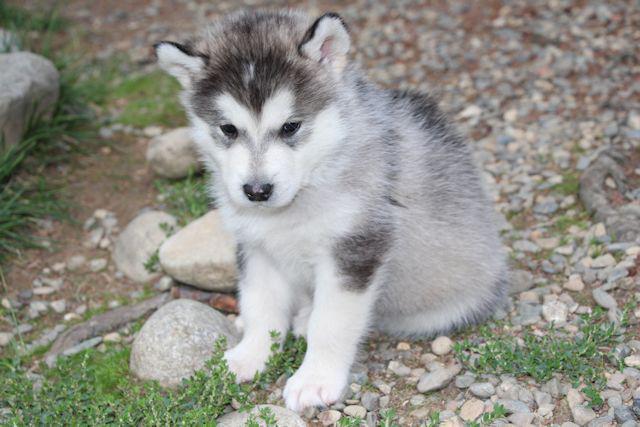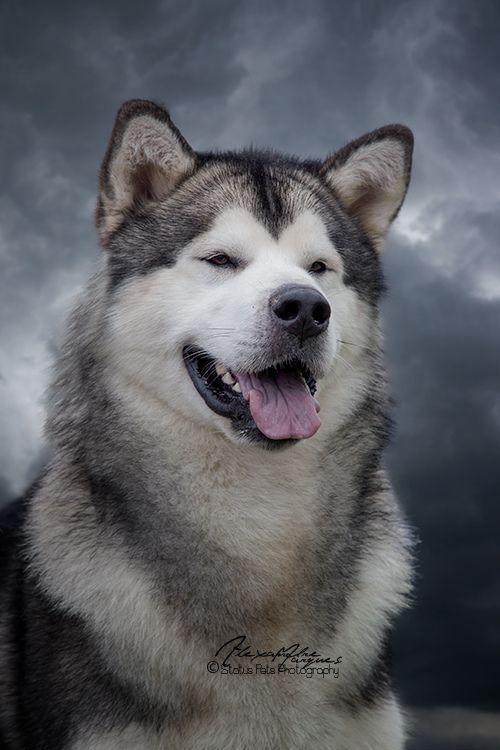The first image is the image on the left, the second image is the image on the right. Given the left and right images, does the statement "One image shows a gray-and-white husky puppy sitting upright, and the other image shows a darker adult husky with its mouth open." hold true? Answer yes or no. Yes. The first image is the image on the left, the second image is the image on the right. For the images shown, is this caption "There is a puppy and an adult dog" true? Answer yes or no. Yes. 